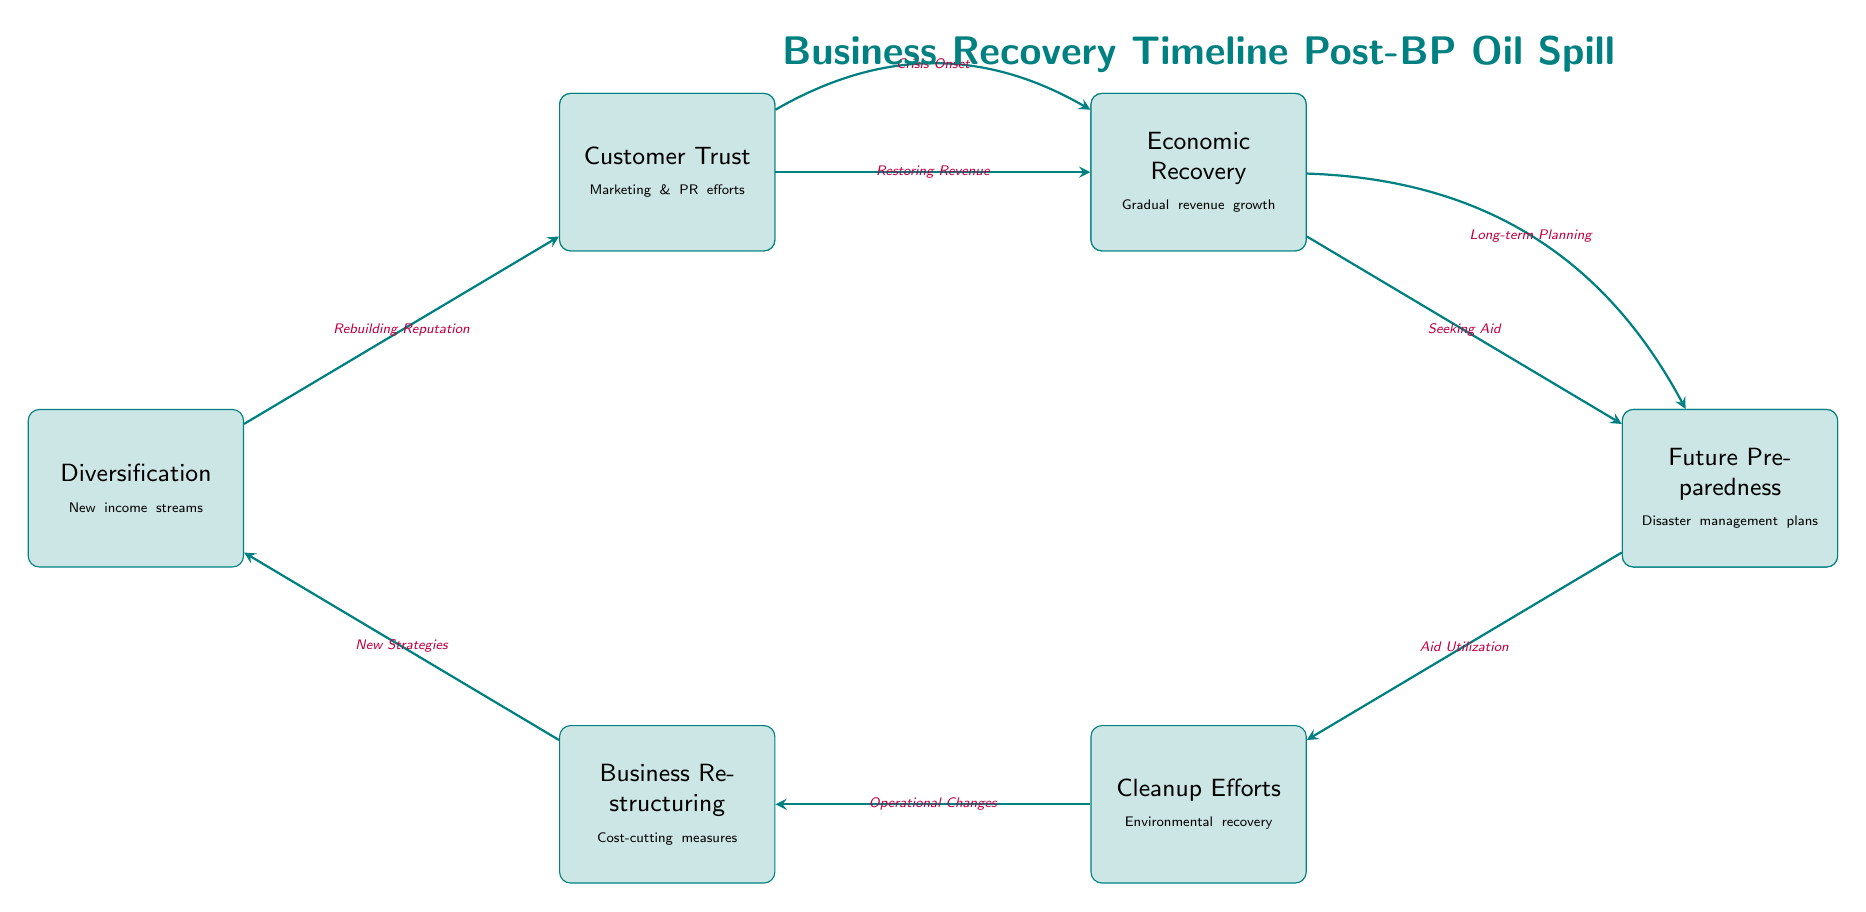What event occurred on April 20, 2010? The diagram specifies that the BP Oil Spill happened on April 20, 2010. This is listed under the first node labeled "BP Oil Spill".
Answer: BP Oil Spill What node follows the 'Initial Financial Hit'? The edge from 'Initial Financial Hit' points directly to the next node, which is 'Government Aid'. This indicates that after experiencing the initial financial impact, businesses sought aid from the government.
Answer: Government Aid How many key recovery milestones are identified in the diagram? By counting the nodes in the diagram, we see there are a total of eight milestones listed, from 'BP Oil Spill' to 'Future Preparedness'.
Answer: 8 What is the edge label between 'Cleanup Efforts' and 'Business Restructuring'? The diagram states that the relationship or edge label between these two nodes is 'Operational Changes'. This indicates that cleanup efforts led to changes in operations and restructuring within the business.
Answer: Operational Changes What milestone comes after 'Customer Trust'? Looking at the diagram, the node that follows 'Customer Trust' is 'Economic Recovery', which shows the progression from rebuilding customer trust to a gradual revenue growth.
Answer: Economic Recovery Which process is identified as utilizing the government aid? The edge from 'Government Aid' leads to 'Cleanup Efforts', indicating that the aid received was utilized primarily for environmental recovery and cleanup processes.
Answer: Cleanup Efforts What strategy is implied by the arrow leading from 'Business Restructuring'? The arrow shows that 'Business Restructuring' leads to the node 'Diversification', suggesting that one of the strategies after restructuring is to develop new income streams to recover from the financial troubles.
Answer: Diversification 